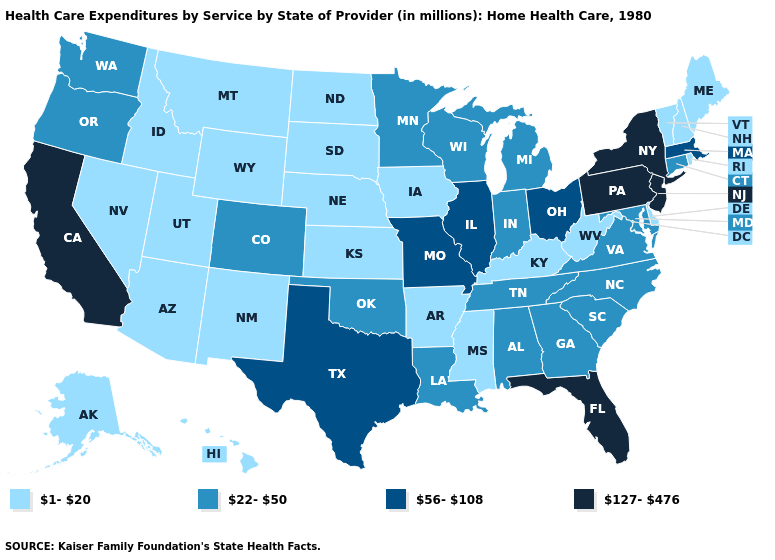How many symbols are there in the legend?
Keep it brief. 4. Name the states that have a value in the range 127-476?
Keep it brief. California, Florida, New Jersey, New York, Pennsylvania. Name the states that have a value in the range 22-50?
Keep it brief. Alabama, Colorado, Connecticut, Georgia, Indiana, Louisiana, Maryland, Michigan, Minnesota, North Carolina, Oklahoma, Oregon, South Carolina, Tennessee, Virginia, Washington, Wisconsin. Among the states that border Nebraska , does Iowa have the lowest value?
Short answer required. Yes. What is the lowest value in states that border Vermont?
Be succinct. 1-20. Name the states that have a value in the range 56-108?
Give a very brief answer. Illinois, Massachusetts, Missouri, Ohio, Texas. Does the map have missing data?
Write a very short answer. No. Which states have the lowest value in the USA?
Short answer required. Alaska, Arizona, Arkansas, Delaware, Hawaii, Idaho, Iowa, Kansas, Kentucky, Maine, Mississippi, Montana, Nebraska, Nevada, New Hampshire, New Mexico, North Dakota, Rhode Island, South Dakota, Utah, Vermont, West Virginia, Wyoming. Name the states that have a value in the range 127-476?
Keep it brief. California, Florida, New Jersey, New York, Pennsylvania. Does Connecticut have a higher value than Louisiana?
Quick response, please. No. What is the lowest value in the USA?
Write a very short answer. 1-20. What is the value of Georgia?
Be succinct. 22-50. What is the value of Arizona?
Give a very brief answer. 1-20. What is the value of North Carolina?
Write a very short answer. 22-50. 